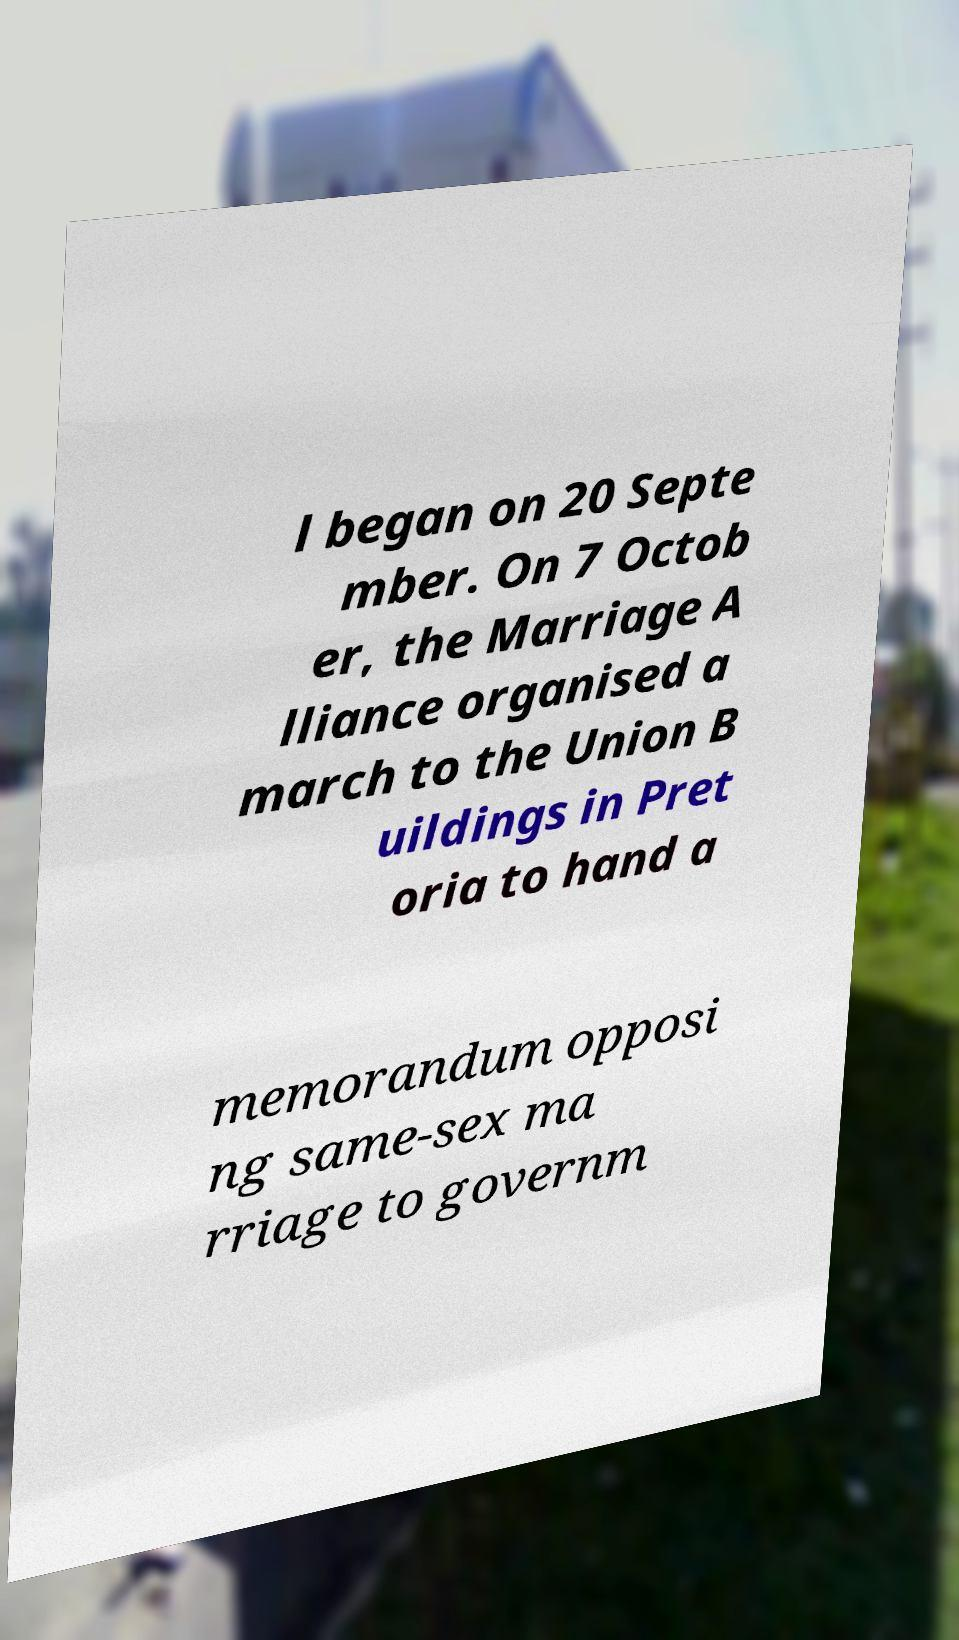Can you read and provide the text displayed in the image?This photo seems to have some interesting text. Can you extract and type it out for me? l began on 20 Septe mber. On 7 Octob er, the Marriage A lliance organised a march to the Union B uildings in Pret oria to hand a memorandum opposi ng same-sex ma rriage to governm 